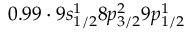<formula> <loc_0><loc_0><loc_500><loc_500>0 . 9 9 \cdot 9 s _ { 1 / 2 } ^ { 1 } 8 p _ { 3 / 2 } ^ { 2 } 9 p _ { 1 / 2 } ^ { 1 }</formula> 